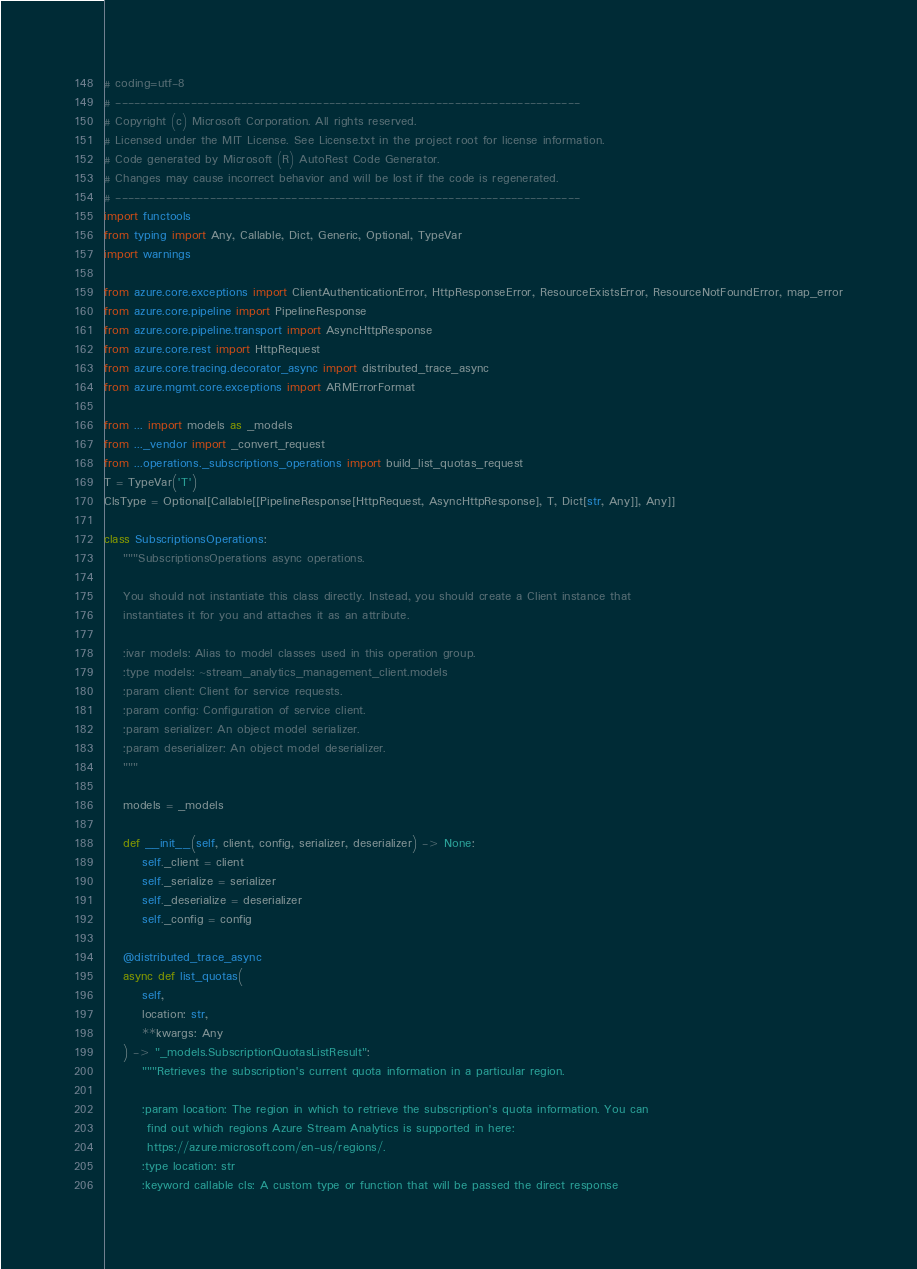<code> <loc_0><loc_0><loc_500><loc_500><_Python_># coding=utf-8
# --------------------------------------------------------------------------
# Copyright (c) Microsoft Corporation. All rights reserved.
# Licensed under the MIT License. See License.txt in the project root for license information.
# Code generated by Microsoft (R) AutoRest Code Generator.
# Changes may cause incorrect behavior and will be lost if the code is regenerated.
# --------------------------------------------------------------------------
import functools
from typing import Any, Callable, Dict, Generic, Optional, TypeVar
import warnings

from azure.core.exceptions import ClientAuthenticationError, HttpResponseError, ResourceExistsError, ResourceNotFoundError, map_error
from azure.core.pipeline import PipelineResponse
from azure.core.pipeline.transport import AsyncHttpResponse
from azure.core.rest import HttpRequest
from azure.core.tracing.decorator_async import distributed_trace_async
from azure.mgmt.core.exceptions import ARMErrorFormat

from ... import models as _models
from ..._vendor import _convert_request
from ...operations._subscriptions_operations import build_list_quotas_request
T = TypeVar('T')
ClsType = Optional[Callable[[PipelineResponse[HttpRequest, AsyncHttpResponse], T, Dict[str, Any]], Any]]

class SubscriptionsOperations:
    """SubscriptionsOperations async operations.

    You should not instantiate this class directly. Instead, you should create a Client instance that
    instantiates it for you and attaches it as an attribute.

    :ivar models: Alias to model classes used in this operation group.
    :type models: ~stream_analytics_management_client.models
    :param client: Client for service requests.
    :param config: Configuration of service client.
    :param serializer: An object model serializer.
    :param deserializer: An object model deserializer.
    """

    models = _models

    def __init__(self, client, config, serializer, deserializer) -> None:
        self._client = client
        self._serialize = serializer
        self._deserialize = deserializer
        self._config = config

    @distributed_trace_async
    async def list_quotas(
        self,
        location: str,
        **kwargs: Any
    ) -> "_models.SubscriptionQuotasListResult":
        """Retrieves the subscription's current quota information in a particular region.

        :param location: The region in which to retrieve the subscription's quota information. You can
         find out which regions Azure Stream Analytics is supported in here:
         https://azure.microsoft.com/en-us/regions/.
        :type location: str
        :keyword callable cls: A custom type or function that will be passed the direct response</code> 